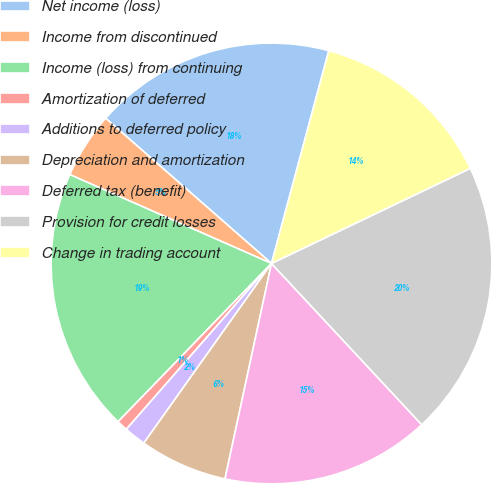<chart> <loc_0><loc_0><loc_500><loc_500><pie_chart><fcel>Net income (loss)<fcel>Income from discontinued<fcel>Income (loss) from continuing<fcel>Amortization of deferred<fcel>Additions to deferred policy<fcel>Depreciation and amortization<fcel>Deferred tax (benefit)<fcel>Provision for credit losses<fcel>Change in trading account<nl><fcel>17.74%<fcel>4.84%<fcel>19.35%<fcel>0.81%<fcel>1.61%<fcel>6.45%<fcel>15.32%<fcel>20.16%<fcel>13.71%<nl></chart> 